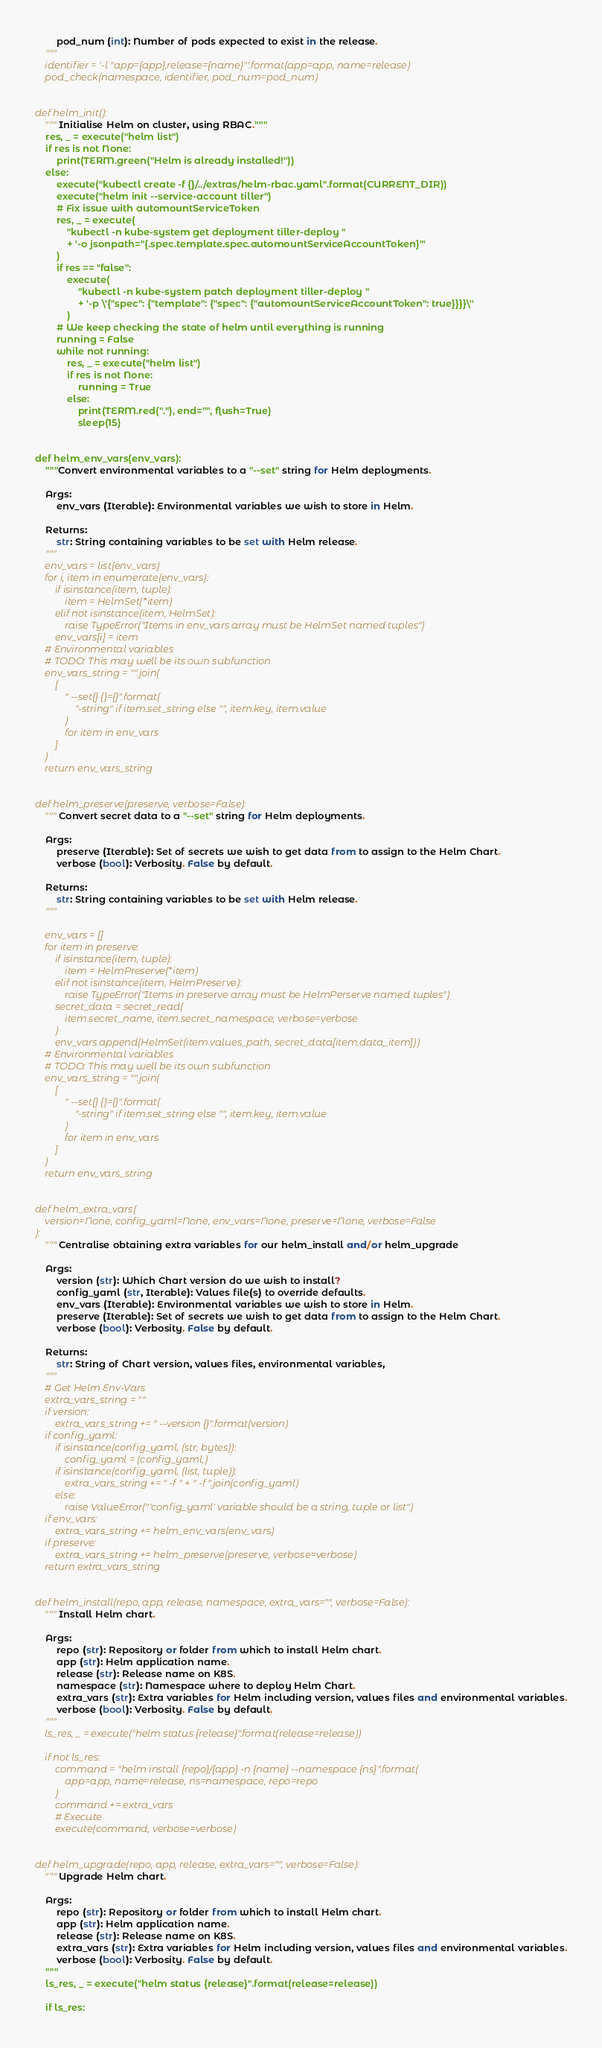<code> <loc_0><loc_0><loc_500><loc_500><_Python_>        pod_num (int): Number of pods expected to exist in the release.
    """
    identifier = '-l "app={app},release={name}"'.format(app=app, name=release)
    pod_check(namespace, identifier, pod_num=pod_num)


def helm_init():
    """Initialise Helm on cluster, using RBAC."""
    res, _ = execute("helm list")
    if res is not None:
        print(TERM.green("Helm is already installed!"))
    else:
        execute("kubectl create -f {}/../extras/helm-rbac.yaml".format(CURRENT_DIR))
        execute("helm init --service-account tiller")
        # Fix issue with automountServiceToken
        res, _ = execute(
            "kubectl -n kube-system get deployment tiller-deploy "
            + '-o jsonpath="{.spec.template.spec.automountServiceAccountToken}"'
        )
        if res == "false":
            execute(
                "kubectl -n kube-system patch deployment tiller-deploy "
                + '-p \'{"spec": {"template": {"spec": {"automountServiceAccountToken": true}}}}\''
            )
        # We keep checking the state of helm until everything is running
        running = False
        while not running:
            res, _ = execute("helm list")
            if res is not None:
                running = True
            else:
                print(TERM.red("."), end="", flush=True)
                sleep(15)


def helm_env_vars(env_vars):
    """Convert environmental variables to a "--set" string for Helm deployments.

    Args:
        env_vars (Iterable): Environmental variables we wish to store in Helm.

    Returns:
        str: String containing variables to be set with Helm release.
    """
    env_vars = list(env_vars)
    for i, item in enumerate(env_vars):
        if isinstance(item, tuple):
            item = HelmSet(*item)
        elif not isinstance(item, HelmSet):
            raise TypeError("Items in env_vars array must be HelmSet named tuples")
        env_vars[i] = item
    # Environmental variables
    # TODO: This may well be its own subfunction
    env_vars_string = "".join(
        [
            " --set{} {}={}".format(
                "-string" if item.set_string else "", item.key, item.value
            )
            for item in env_vars
        ]
    )
    return env_vars_string


def helm_preserve(preserve, verbose=False):
    """Convert secret data to a "--set" string for Helm deployments.

    Args:
        preserve (Iterable): Set of secrets we wish to get data from to assign to the Helm Chart.
        verbose (bool): Verbosity. False by default.

    Returns:
        str: String containing variables to be set with Helm release.
    """

    env_vars = []
    for item in preserve:
        if isinstance(item, tuple):
            item = HelmPreserve(*item)
        elif not isinstance(item, HelmPreserve):
            raise TypeError("Items in preserve array must be HelmPerserve named tuples")
        secret_data = secret_read(
            item.secret_name, item.secret_namespace, verbose=verbose
        )
        env_vars.append(HelmSet(item.values_path, secret_data[item.data_item]))
    # Environmental variables
    # TODO: This may well be its own subfunction
    env_vars_string = "".join(
        [
            " --set{} {}={}".format(
                "-string" if item.set_string else "", item.key, item.value
            )
            for item in env_vars
        ]
    )
    return env_vars_string


def helm_extra_vars(
    version=None, config_yaml=None, env_vars=None, preserve=None, verbose=False
):
    """Centralise obtaining extra variables for our helm_install and/or helm_upgrade

    Args:
        version (str): Which Chart version do we wish to install?
        config_yaml (str, Iterable): Values file(s) to override defaults.
        env_vars (Iterable): Environmental variables we wish to store in Helm.
        preserve (Iterable): Set of secrets we wish to get data from to assign to the Helm Chart.
        verbose (bool): Verbosity. False by default.

    Returns:
        str: String of Chart version, values files, environmental variables,
    """
    # Get Helm Env-Vars
    extra_vars_string = ""
    if version:
        extra_vars_string += " --version {}".format(version)
    if config_yaml:
        if isinstance(config_yaml, (str, bytes)):
            config_yaml = (config_yaml,)
        if isinstance(config_yaml, (list, tuple)):
            extra_vars_string += " -f " + " -f ".join(config_yaml)
        else:
            raise ValueError("'config_yaml' variable should be a string, tuple or list")
    if env_vars:
        extra_vars_string += helm_env_vars(env_vars)
    if preserve:
        extra_vars_string += helm_preserve(preserve, verbose=verbose)
    return extra_vars_string


def helm_install(repo, app, release, namespace, extra_vars="", verbose=False):
    """Install Helm chart.

    Args:
        repo (str): Repository or folder from which to install Helm chart.
        app (str): Helm application name.
        release (str): Release name on K8S.
        namespace (str): Namespace where to deploy Helm Chart.
        extra_vars (str): Extra variables for Helm including version, values files and environmental variables.
        verbose (bool): Verbosity. False by default.
    """
    ls_res, _ = execute("helm status {release}".format(release=release))

    if not ls_res:
        command = "helm install {repo}/{app} -n {name} --namespace {ns}".format(
            app=app, name=release, ns=namespace, repo=repo
        )
        command += extra_vars
        # Execute
        execute(command, verbose=verbose)


def helm_upgrade(repo, app, release, extra_vars="", verbose=False):
    """Upgrade Helm chart.

    Args:
        repo (str): Repository or folder from which to install Helm chart.
        app (str): Helm application name.
        release (str): Release name on K8S.
        extra_vars (str): Extra variables for Helm including version, values files and environmental variables.
        verbose (bool): Verbosity. False by default.
    """
    ls_res, _ = execute("helm status {release}".format(release=release))

    if ls_res:</code> 